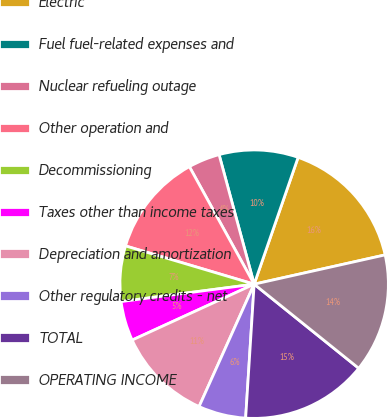Convert chart. <chart><loc_0><loc_0><loc_500><loc_500><pie_chart><fcel>Electric<fcel>Fuel fuel-related expenses and<fcel>Nuclear refueling outage<fcel>Other operation and<fcel>Decommissioning<fcel>Taxes other than income taxes<fcel>Depreciation and amortization<fcel>Other regulatory credits - net<fcel>TOTAL<fcel>OPERATING INCOME<nl><fcel>16.19%<fcel>9.52%<fcel>3.81%<fcel>12.38%<fcel>6.67%<fcel>4.77%<fcel>11.43%<fcel>5.72%<fcel>15.23%<fcel>14.28%<nl></chart> 